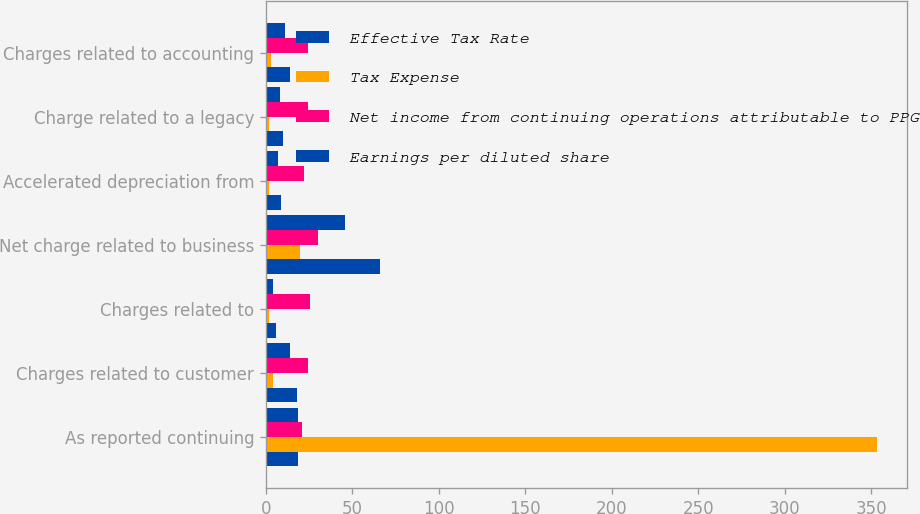<chart> <loc_0><loc_0><loc_500><loc_500><stacked_bar_chart><ecel><fcel>As reported continuing<fcel>Charges related to customer<fcel>Charges related to<fcel>Net charge related to business<fcel>Accelerated depreciation from<fcel>Charge related to a legacy<fcel>Charges related to accounting<nl><fcel>Effective Tax Rate<fcel>18.5<fcel>18<fcel>6<fcel>66<fcel>9<fcel>10<fcel>14<nl><fcel>Tax Expense<fcel>353<fcel>4<fcel>2<fcel>20<fcel>2<fcel>2<fcel>3<nl><fcel>Net income from continuing operations attributable to PPG<fcel>20.9<fcel>24.3<fcel>25.5<fcel>30.3<fcel>22.2<fcel>24.3<fcel>24.3<nl><fcel>Earnings per diluted share<fcel>18.5<fcel>14<fcel>4<fcel>46<fcel>7<fcel>8<fcel>11<nl></chart> 